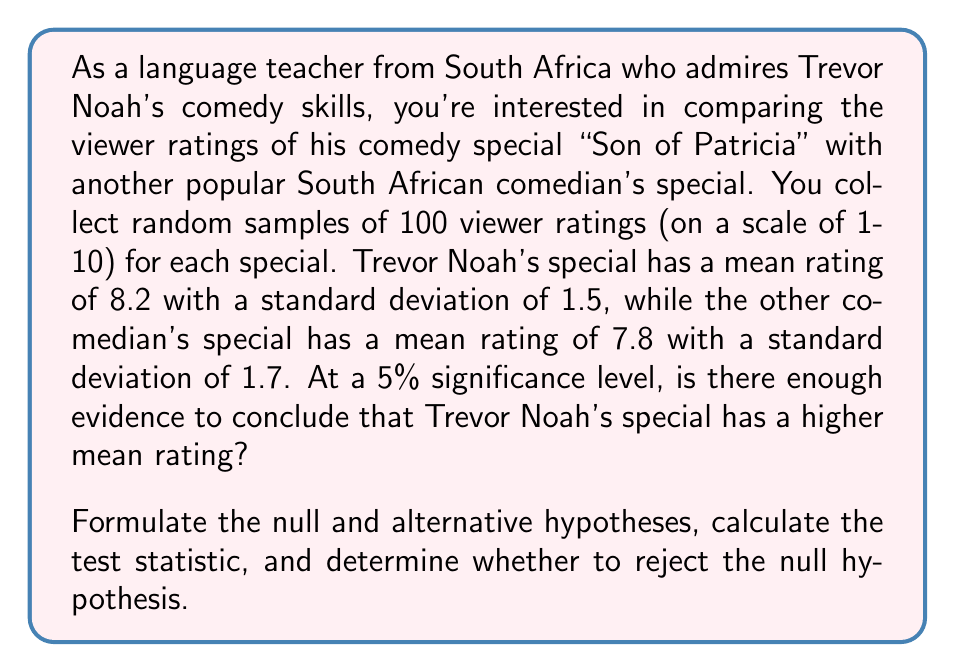Solve this math problem. To solve this problem, we'll follow these steps:

1. Formulate the null and alternative hypotheses:
   $H_0: \mu_1 - \mu_2 = 0$ (There is no difference in mean ratings)
   $H_a: \mu_1 - \mu_2 > 0$ (Trevor Noah's special has a higher mean rating)

2. Choose the significance level:
   $\alpha = 0.05$ (given in the question)

3. Calculate the test statistic (z-score) for the difference between two means:

   $$z = \frac{(\bar{x}_1 - \bar{x}_2) - (\mu_1 - \mu_2)_0}{\sqrt{\frac{s_1^2}{n_1} + \frac{s_2^2}{n_2}}}$$

   Where:
   $\bar{x}_1 = 8.2$ (Trevor Noah's mean rating)
   $\bar{x}_2 = 7.8$ (Other comedian's mean rating)
   $s_1 = 1.5$ (Trevor Noah's standard deviation)
   $s_2 = 1.7$ (Other comedian's standard deviation)
   $n_1 = n_2 = 100$ (sample sizes)
   $(\mu_1 - \mu_2)_0 = 0$ (null hypothesis assumes no difference)

   Plugging in the values:

   $$z = \frac{(8.2 - 7.8) - 0}{\sqrt{\frac{1.5^2}{100} + \frac{1.7^2}{100}}}$$

   $$z = \frac{0.4}{\sqrt{0.0225 + 0.0289}} = \frac{0.4}{\sqrt{0.0514}} = \frac{0.4}{0.2267} = 1.7645$$

4. Find the critical value:
   For a one-tailed test at $\alpha = 0.05$, the critical z-value is 1.645.

5. Compare the test statistic to the critical value:
   Since 1.7645 > 1.645, we reject the null hypothesis.

6. Interpret the results:
   At a 5% significance level, there is enough evidence to conclude that Trevor Noah's comedy special "Son of Patricia" has a higher mean viewer rating than the other South African comedian's special.
Answer: Reject the null hypothesis. The test statistic (z = 1.7645) is greater than the critical value (1.645) at α = 0.05. There is sufficient evidence to conclude that Trevor Noah's comedy special has a higher mean viewer rating. 